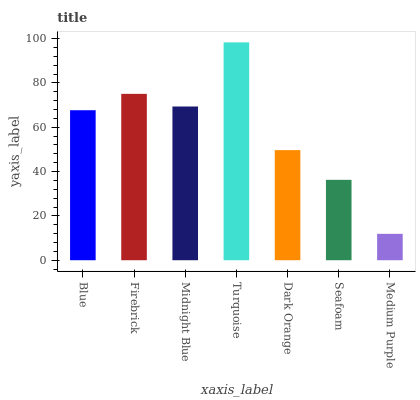Is Medium Purple the minimum?
Answer yes or no. Yes. Is Turquoise the maximum?
Answer yes or no. Yes. Is Firebrick the minimum?
Answer yes or no. No. Is Firebrick the maximum?
Answer yes or no. No. Is Firebrick greater than Blue?
Answer yes or no. Yes. Is Blue less than Firebrick?
Answer yes or no. Yes. Is Blue greater than Firebrick?
Answer yes or no. No. Is Firebrick less than Blue?
Answer yes or no. No. Is Blue the high median?
Answer yes or no. Yes. Is Blue the low median?
Answer yes or no. Yes. Is Dark Orange the high median?
Answer yes or no. No. Is Seafoam the low median?
Answer yes or no. No. 